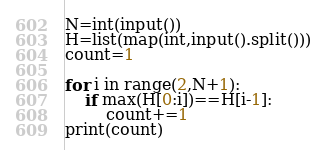Convert code to text. <code><loc_0><loc_0><loc_500><loc_500><_Python_>N=int(input())
H=list(map(int,input().split()))
count=1

for i in range(2,N+1):
    if max(H[0:i])==H[i-1]:
        count+=1
print(count)
</code> 